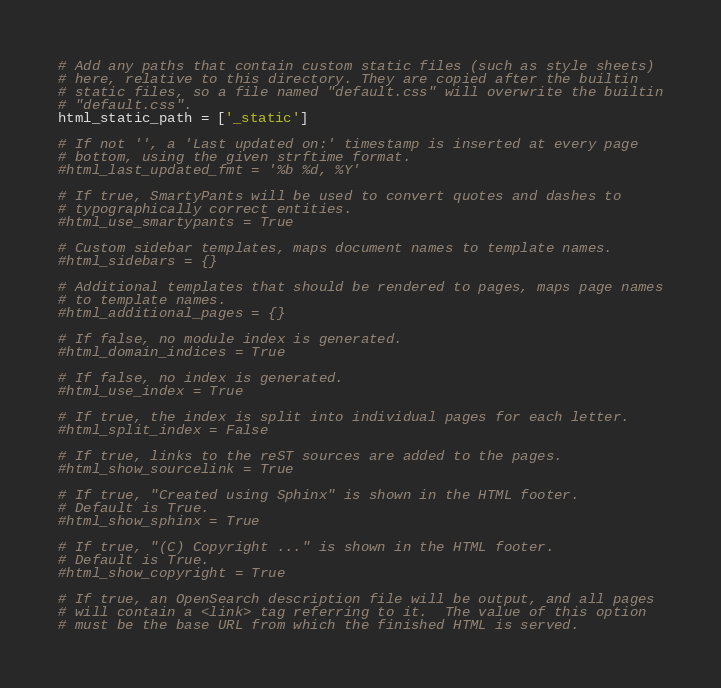Convert code to text. <code><loc_0><loc_0><loc_500><loc_500><_Python_>
# Add any paths that contain custom static files (such as style sheets)
# here, relative to this directory. They are copied after the builtin
# static files, so a file named "default.css" will overwrite the builtin
# "default.css".
html_static_path = ['_static']

# If not '', a 'Last updated on:' timestamp is inserted at every page
# bottom, using the given strftime format.
#html_last_updated_fmt = '%b %d, %Y'

# If true, SmartyPants will be used to convert quotes and dashes to
# typographically correct entities.
#html_use_smartypants = True

# Custom sidebar templates, maps document names to template names.
#html_sidebars = {}

# Additional templates that should be rendered to pages, maps page names
# to template names.
#html_additional_pages = {}

# If false, no module index is generated.
#html_domain_indices = True

# If false, no index is generated.
#html_use_index = True

# If true, the index is split into individual pages for each letter.
#html_split_index = False

# If true, links to the reST sources are added to the pages.
#html_show_sourcelink = True

# If true, "Created using Sphinx" is shown in the HTML footer.
# Default is True.
#html_show_sphinx = True

# If true, "(C) Copyright ..." is shown in the HTML footer.
# Default is True.
#html_show_copyright = True

# If true, an OpenSearch description file will be output, and all pages
# will contain a <link> tag referring to it.  The value of this option
# must be the base URL from which the finished HTML is served.</code> 